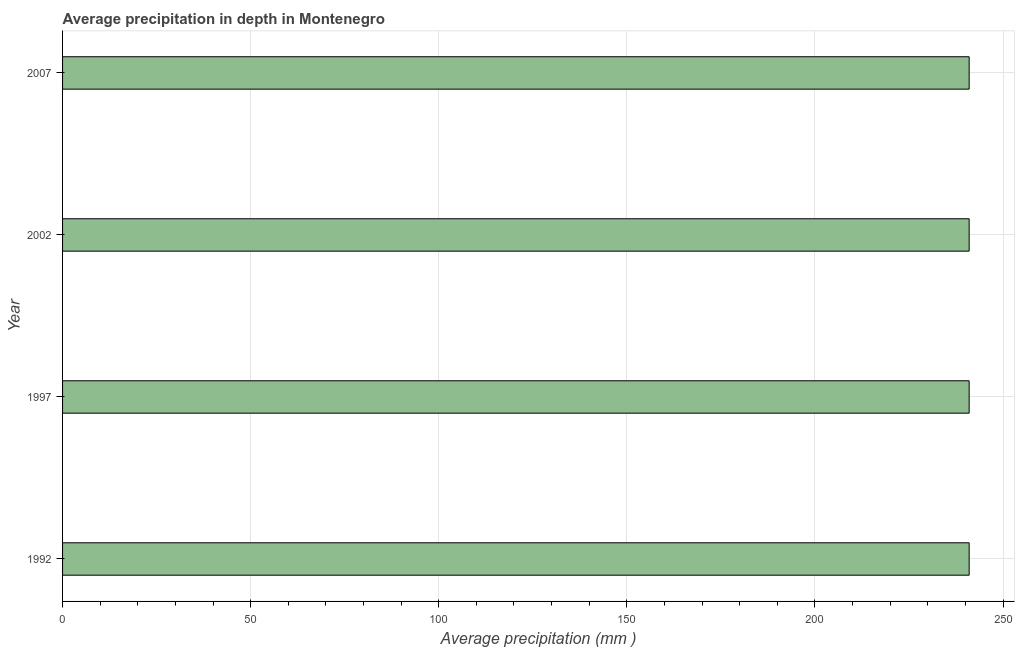Does the graph contain any zero values?
Offer a terse response. No. What is the title of the graph?
Ensure brevity in your answer.  Average precipitation in depth in Montenegro. What is the label or title of the X-axis?
Ensure brevity in your answer.  Average precipitation (mm ). What is the label or title of the Y-axis?
Ensure brevity in your answer.  Year. What is the average precipitation in depth in 2007?
Ensure brevity in your answer.  241. Across all years, what is the maximum average precipitation in depth?
Provide a succinct answer. 241. Across all years, what is the minimum average precipitation in depth?
Keep it short and to the point. 241. In which year was the average precipitation in depth maximum?
Keep it short and to the point. 1992. In which year was the average precipitation in depth minimum?
Your answer should be very brief. 1992. What is the sum of the average precipitation in depth?
Offer a very short reply. 964. What is the average average precipitation in depth per year?
Keep it short and to the point. 241. What is the median average precipitation in depth?
Ensure brevity in your answer.  241. Do a majority of the years between 2002 and 1997 (inclusive) have average precipitation in depth greater than 30 mm?
Ensure brevity in your answer.  No. Is the average precipitation in depth in 1992 less than that in 1997?
Provide a short and direct response. No. Is the difference between the average precipitation in depth in 1997 and 2002 greater than the difference between any two years?
Offer a terse response. Yes. Is the sum of the average precipitation in depth in 1992 and 2007 greater than the maximum average precipitation in depth across all years?
Provide a short and direct response. Yes. What is the difference between the highest and the lowest average precipitation in depth?
Keep it short and to the point. 0. In how many years, is the average precipitation in depth greater than the average average precipitation in depth taken over all years?
Offer a very short reply. 0. How many bars are there?
Ensure brevity in your answer.  4. Are all the bars in the graph horizontal?
Provide a short and direct response. Yes. How many years are there in the graph?
Keep it short and to the point. 4. What is the Average precipitation (mm ) of 1992?
Make the answer very short. 241. What is the Average precipitation (mm ) in 1997?
Make the answer very short. 241. What is the Average precipitation (mm ) of 2002?
Offer a very short reply. 241. What is the Average precipitation (mm ) in 2007?
Make the answer very short. 241. What is the difference between the Average precipitation (mm ) in 1992 and 2002?
Your response must be concise. 0. What is the difference between the Average precipitation (mm ) in 1997 and 2007?
Your response must be concise. 0. What is the ratio of the Average precipitation (mm ) in 1992 to that in 2002?
Make the answer very short. 1. What is the ratio of the Average precipitation (mm ) in 1992 to that in 2007?
Provide a succinct answer. 1. What is the ratio of the Average precipitation (mm ) in 1997 to that in 2002?
Ensure brevity in your answer.  1. 